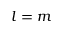<formula> <loc_0><loc_0><loc_500><loc_500>l = m</formula> 